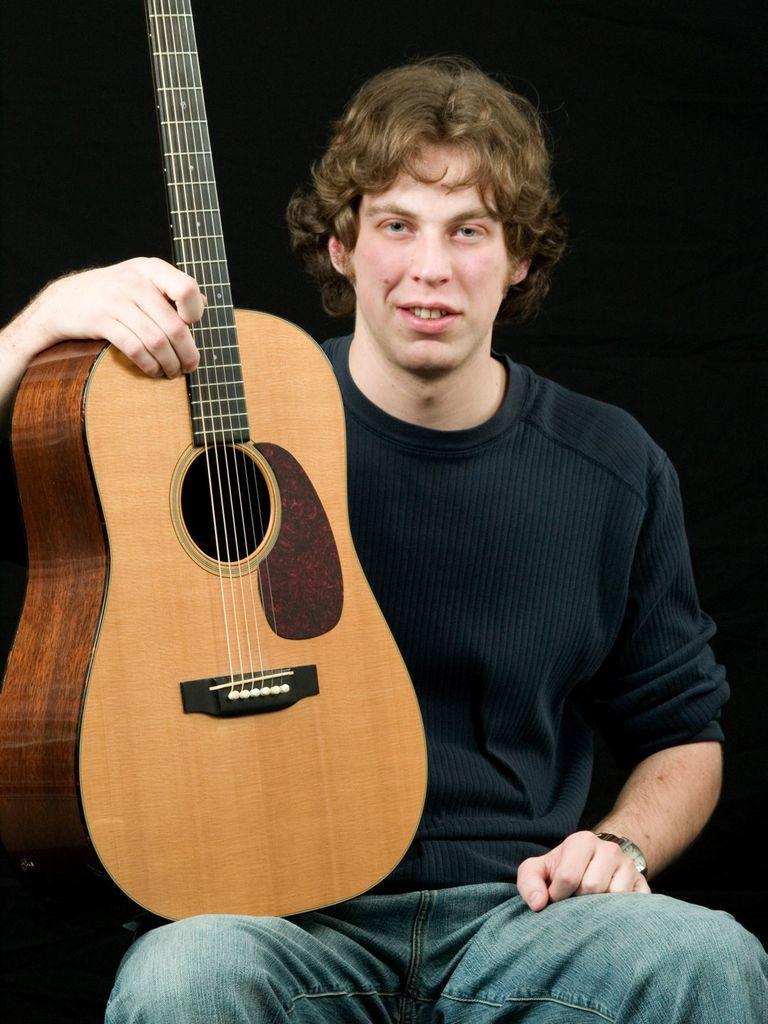Please provide a concise description of this image. In this image there is a man with black color shirt, a watch and a jeans pant sitting in a chair and holding a guitar. 